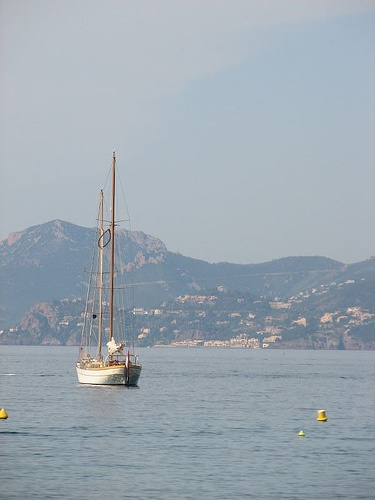Describe the objects in this image and their specific colors. I can see a boat in darkgray and gray tones in this image. 